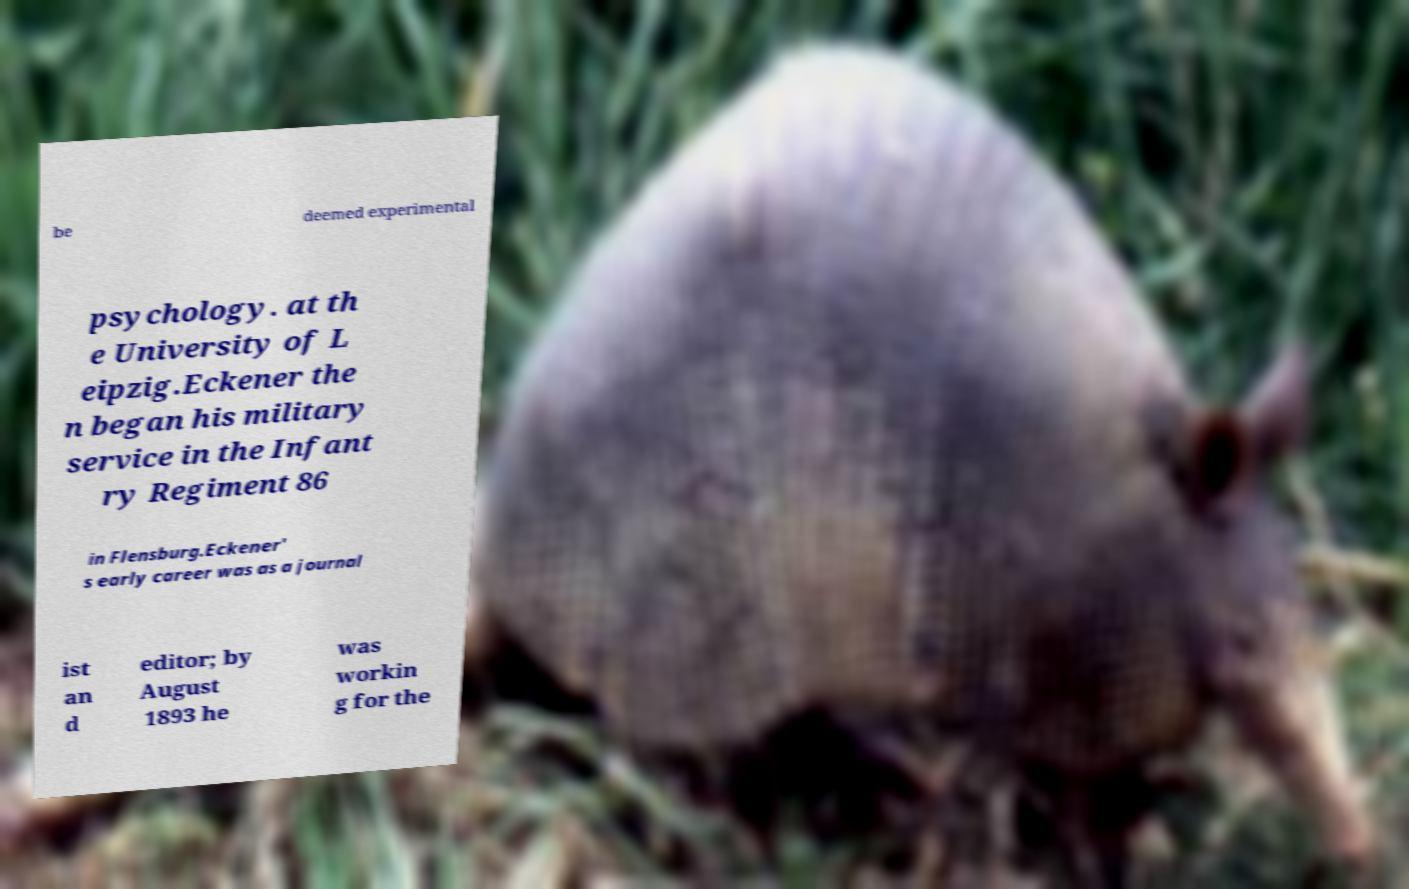For documentation purposes, I need the text within this image transcribed. Could you provide that? be deemed experimental psychology. at th e University of L eipzig.Eckener the n began his military service in the Infant ry Regiment 86 in Flensburg.Eckener' s early career was as a journal ist an d editor; by August 1893 he was workin g for the 